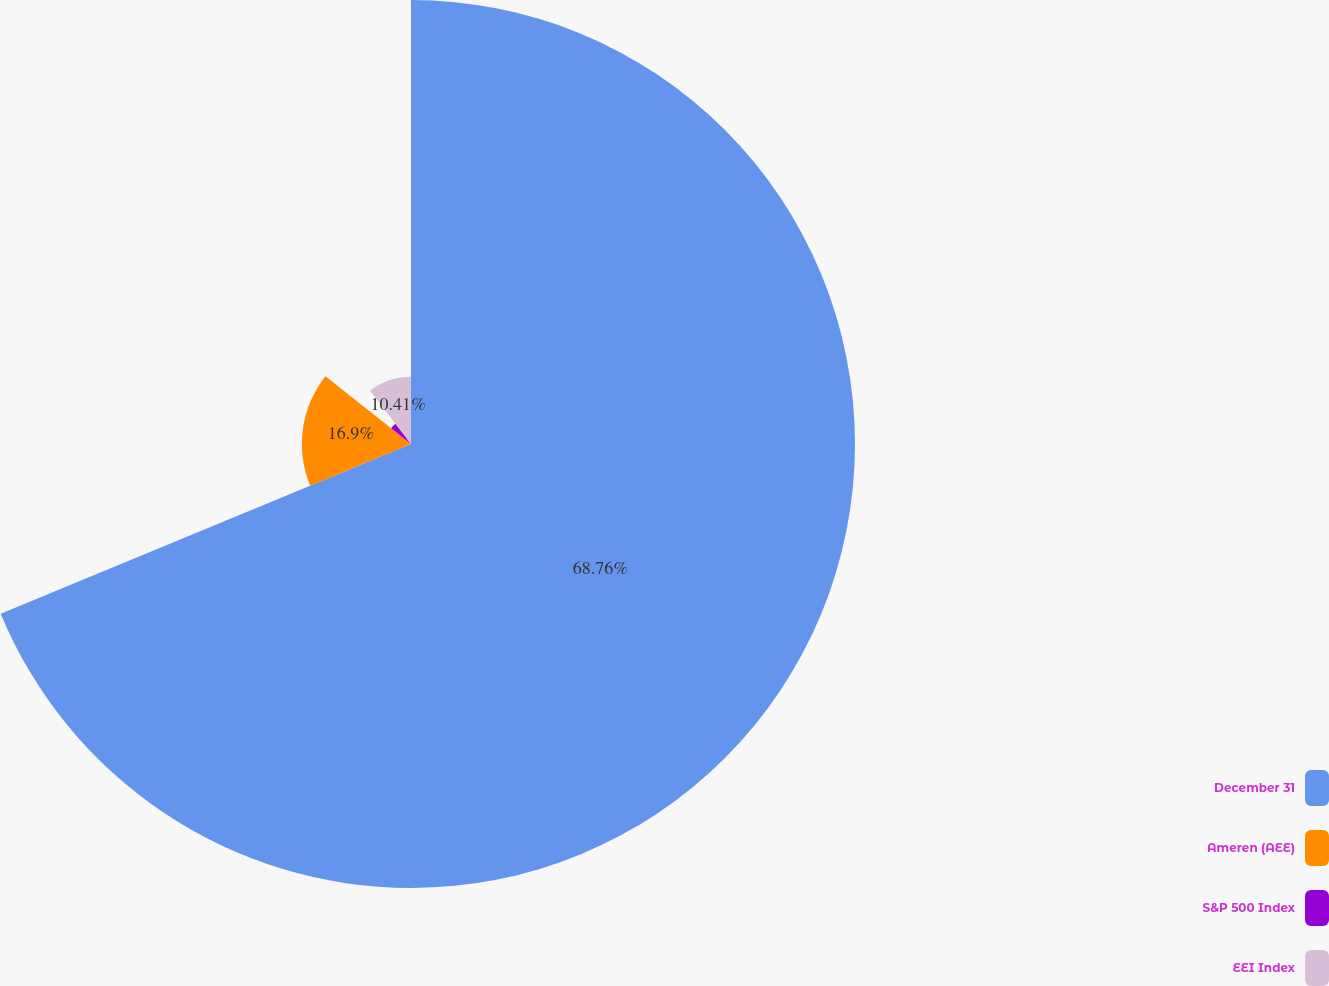<chart> <loc_0><loc_0><loc_500><loc_500><pie_chart><fcel>December 31<fcel>Ameren (AEE)<fcel>S&P 500 Index<fcel>EEI Index<nl><fcel>68.76%<fcel>16.9%<fcel>3.93%<fcel>10.41%<nl></chart> 